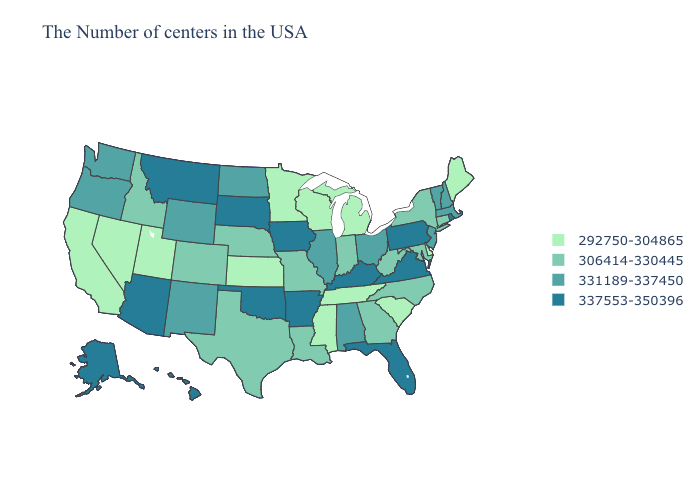Which states have the highest value in the USA?
Answer briefly. Rhode Island, Pennsylvania, Virginia, Florida, Kentucky, Arkansas, Iowa, Oklahoma, South Dakota, Montana, Arizona, Alaska, Hawaii. Name the states that have a value in the range 306414-330445?
Give a very brief answer. Connecticut, New York, Maryland, North Carolina, West Virginia, Georgia, Indiana, Louisiana, Missouri, Nebraska, Texas, Colorado, Idaho. Does Texas have the highest value in the South?
Give a very brief answer. No. Among the states that border West Virginia , does Maryland have the highest value?
Keep it brief. No. Is the legend a continuous bar?
Write a very short answer. No. Does Maine have the lowest value in the Northeast?
Answer briefly. Yes. Name the states that have a value in the range 306414-330445?
Keep it brief. Connecticut, New York, Maryland, North Carolina, West Virginia, Georgia, Indiana, Louisiana, Missouri, Nebraska, Texas, Colorado, Idaho. Does the first symbol in the legend represent the smallest category?
Give a very brief answer. Yes. Which states have the lowest value in the Northeast?
Short answer required. Maine. Does Illinois have the highest value in the USA?
Concise answer only. No. What is the value of North Dakota?
Write a very short answer. 331189-337450. Which states have the lowest value in the USA?
Give a very brief answer. Maine, Delaware, South Carolina, Michigan, Tennessee, Wisconsin, Mississippi, Minnesota, Kansas, Utah, Nevada, California. Does the first symbol in the legend represent the smallest category?
Write a very short answer. Yes. Name the states that have a value in the range 292750-304865?
Keep it brief. Maine, Delaware, South Carolina, Michigan, Tennessee, Wisconsin, Mississippi, Minnesota, Kansas, Utah, Nevada, California. Which states hav the highest value in the West?
Give a very brief answer. Montana, Arizona, Alaska, Hawaii. 